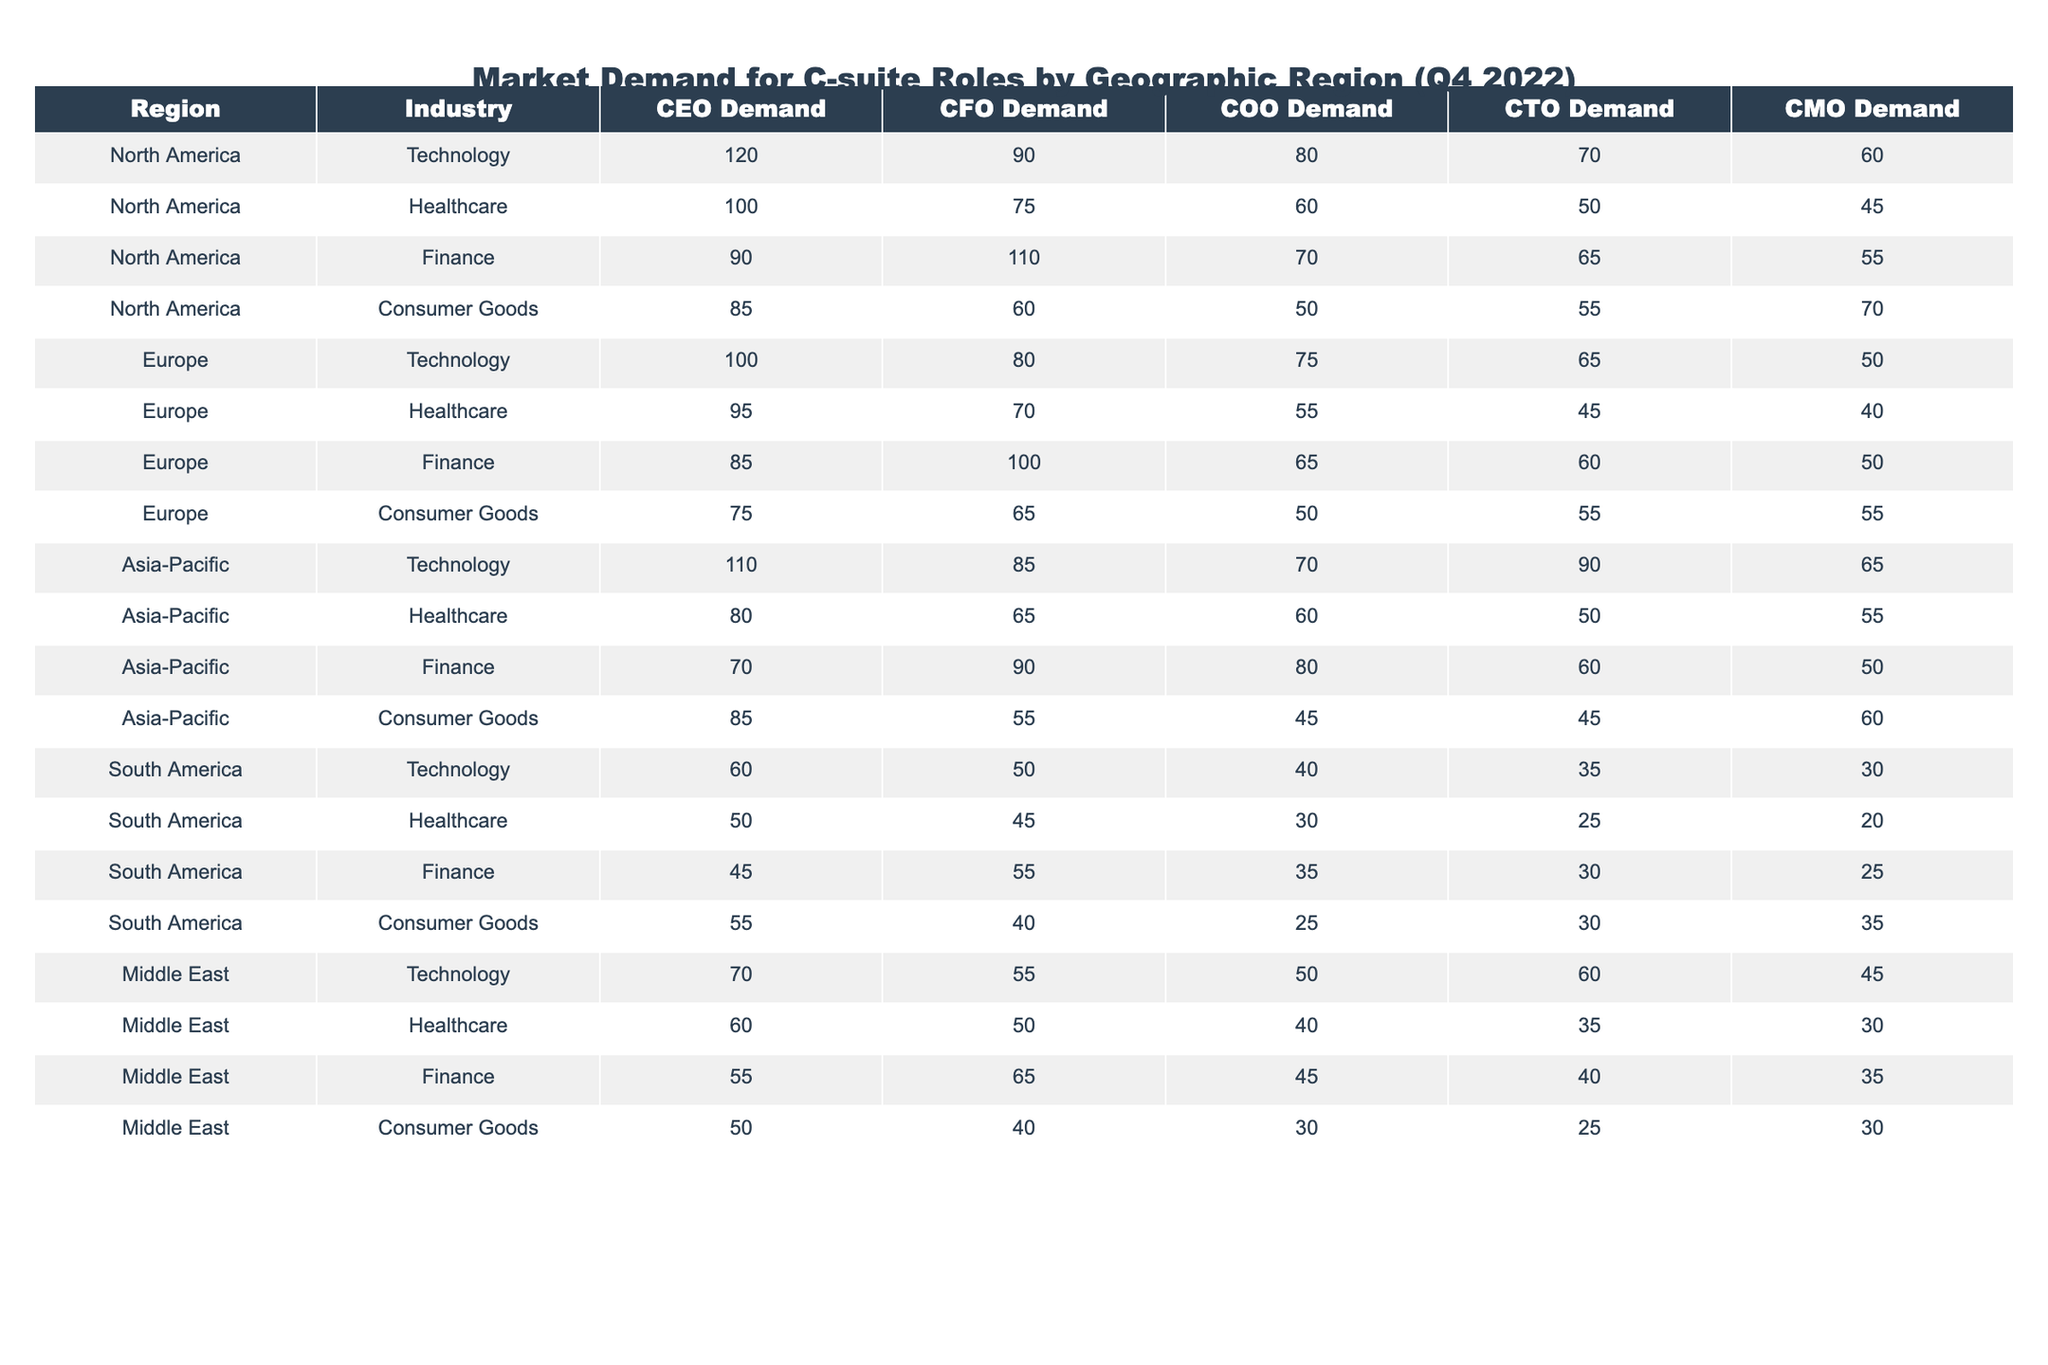What region has the highest demand for CEOs? Looking at the demand for CEOs across all regions, North America has the highest number at 120.
Answer: North America Which industry in South America has the lowest demand for CMOs? From the table, the Healthcare industry in South America has the lowest demand for CMOs at 20.
Answer: 20 What is the total demand for CFOs across all regions in the Finance industry? Adding the demand for CFOs in the Finance industry across all regions: 110 (North America) + 100 (Europe) + 90 (Asia-Pacific) + 55 (South America) = 355.
Answer: 355 Is the demand for COOs in the Asia-Pacific higher than in Europe? In the Asia-Pacific region, the COO demand is 70, while in Europe it is 75. Therefore, the COO demand in Asia-Pacific is lower than in Europe.
Answer: False Which region has the highest total demand for C-suite roles in the Technology industry? Summing the demands for Technology positions in each region: North America (120 + 90 + 80 + 70 + 60 = 420), Europe (100 + 80 + 75 + 65 + 50 = 370), Asia-Pacific (110 + 85 + 70 + 90 + 65 = 420), South America (60 + 50 + 40 + 35 + 30 = 215), Middle East (70 + 55 + 50 + 60 + 45 = 330). North America and Asia-Pacific have the same total, but North America has the edge in CEO demand.
Answer: North America What is the average COO demand across all regions? The COO demands are: 80 (North America) + 60 + 70 + 50 (Consumer Goods) + 75 (Europe) + 55 + 65 + 50 + 70 (Asia-Pacific) + 60 + 45 + 30 + 40 (South America) + 50 + 40 + 30 (Middle East) = 820. There are 15 total entries, so the average is 820/15 = 54.67 (rounded).
Answer: Approximately 54.67 Does the demand for CEOs in Healthcare exceed that in Consumer Goods in North America? In North America, the demand for CEOs is 100 in Healthcare and 85 in Consumer Goods; hence it does exceed it.
Answer: True What is the difference in demand for CTOs between North America and South America? In North America, the demand for CTOs is 70, while in South America it is 35. The difference is 70 - 35 = 35.
Answer: 35 